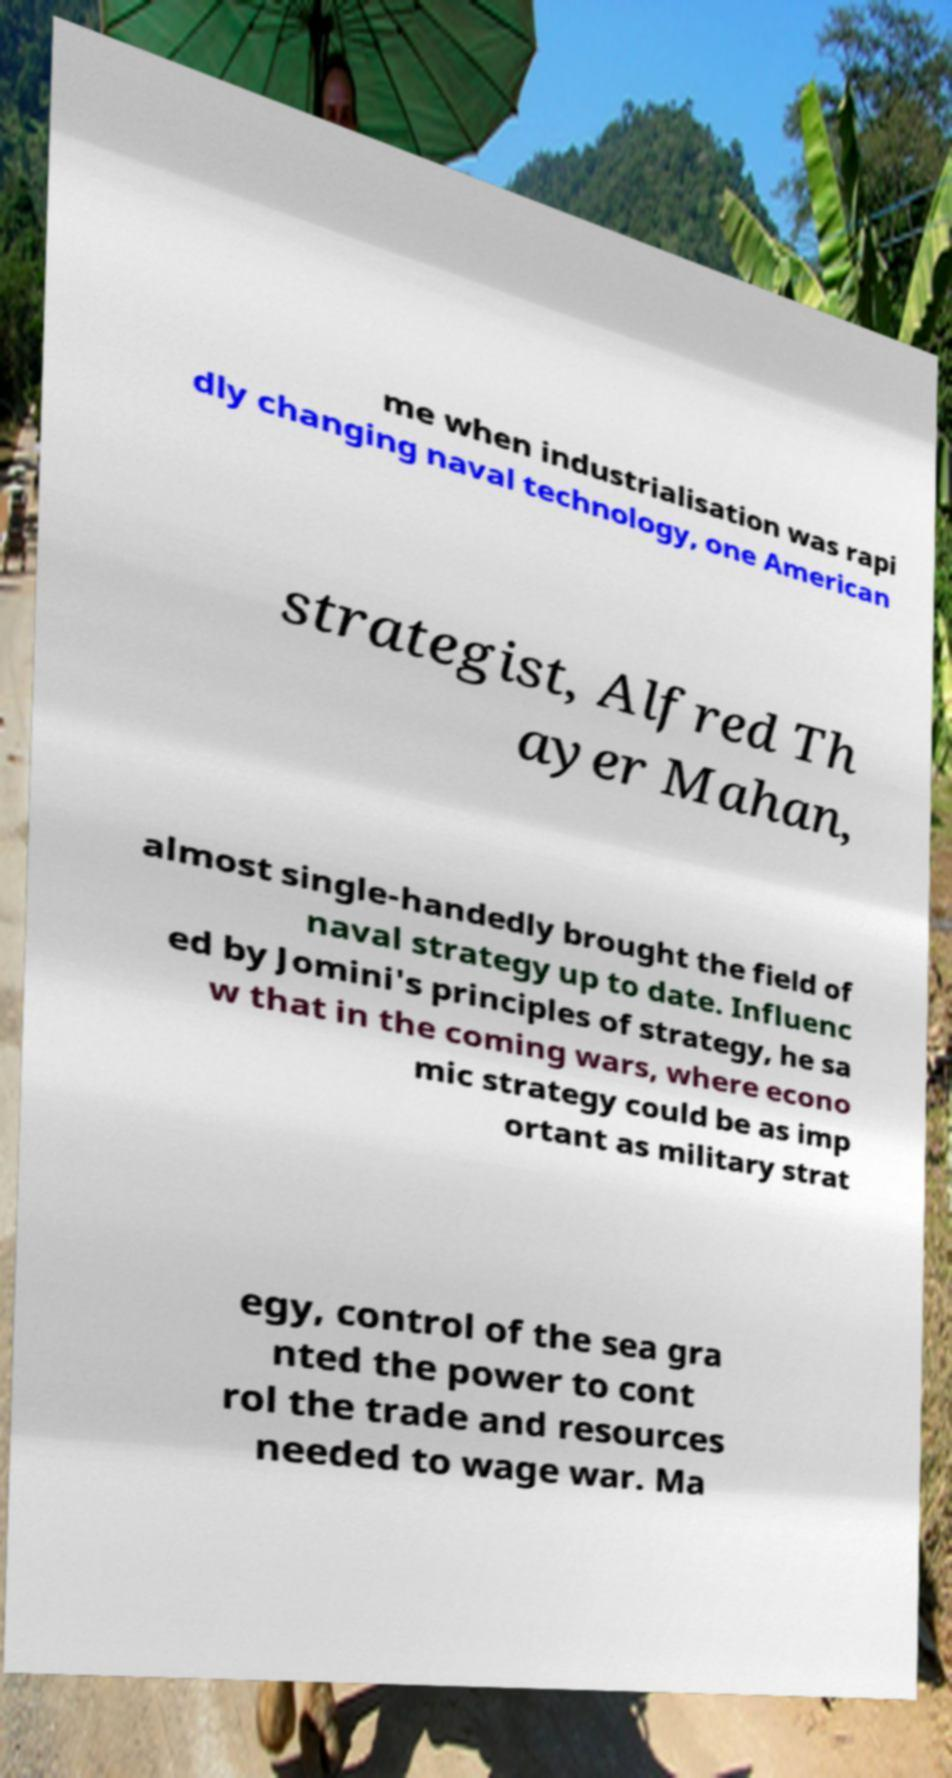Please read and relay the text visible in this image. What does it say? me when industrialisation was rapi dly changing naval technology, one American strategist, Alfred Th ayer Mahan, almost single-handedly brought the field of naval strategy up to date. Influenc ed by Jomini's principles of strategy, he sa w that in the coming wars, where econo mic strategy could be as imp ortant as military strat egy, control of the sea gra nted the power to cont rol the trade and resources needed to wage war. Ma 